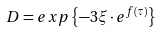<formula> <loc_0><loc_0><loc_500><loc_500>D = e x p \left \{ - 3 \xi \cdot e ^ { f \left ( \tau \right ) } \right \}</formula> 